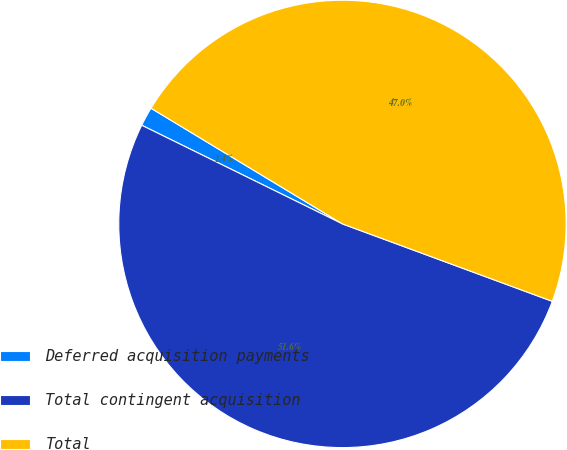Convert chart to OTSL. <chart><loc_0><loc_0><loc_500><loc_500><pie_chart><fcel>Deferred acquisition payments<fcel>Total contingent acquisition<fcel>Total<nl><fcel>1.38%<fcel>51.64%<fcel>46.97%<nl></chart> 